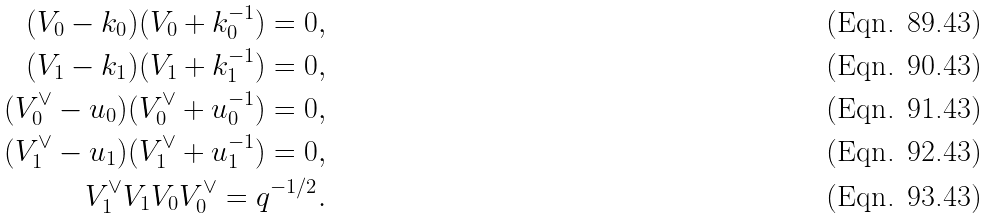Convert formula to latex. <formula><loc_0><loc_0><loc_500><loc_500>( V _ { 0 } - k _ { 0 } ) ( V _ { 0 } + k _ { 0 } ^ { - 1 } ) = 0 , \\ ( V _ { 1 } - k _ { 1 } ) ( V _ { 1 } + k _ { 1 } ^ { - 1 } ) = 0 , \\ ( V _ { 0 } ^ { \vee } - u _ { 0 } ) ( V ^ { \vee } _ { 0 } + u _ { 0 } ^ { - 1 } ) = 0 , \\ ( V _ { 1 } ^ { \vee } - u _ { 1 } ) ( V _ { 1 } ^ { \vee } + u _ { 1 } ^ { - 1 } ) = 0 , \\ V _ { 1 } ^ { \vee } V _ { 1 } V _ { 0 } V _ { 0 } ^ { \vee } = q ^ { - 1 / 2 } .</formula> 